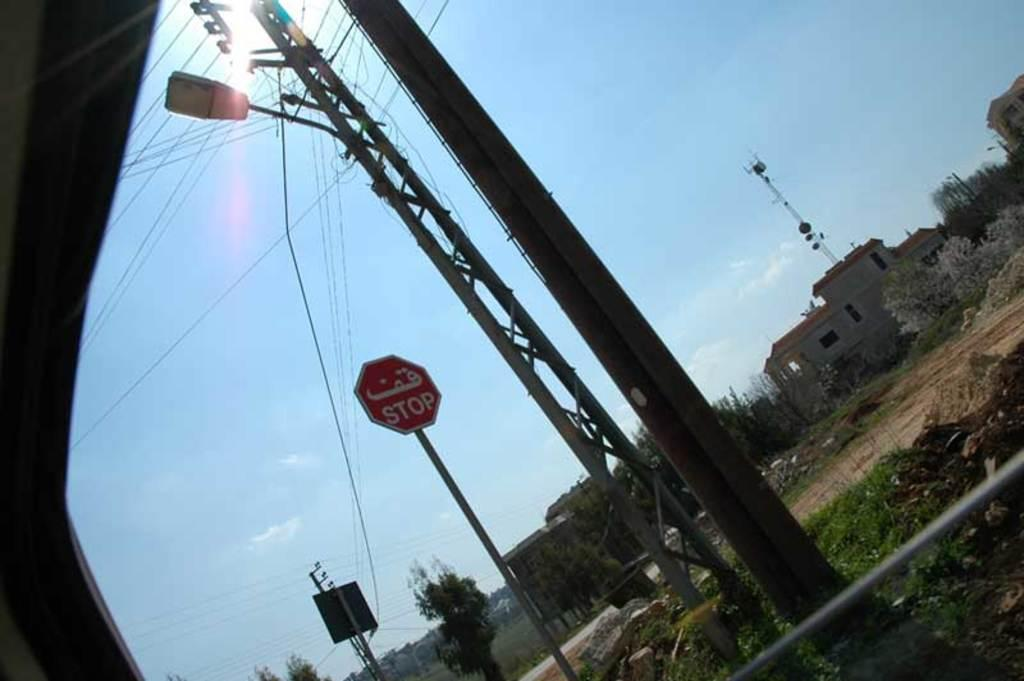What type of structures are present in the image? There are sign boards, poles, power line cables, trees, buildings, and stones visible in the image. What type of surface can be seen in the image? A road is visible in the image. What is visible at the top of the image? There is a sunset at the top of the image. What is the background of the image? The sky is visible in the image. How many sisters are playing basketball in the image? There are no sisters or basketball present in the image. What type of metal is used to make the lead in the image? There is no lead present in the image, and therefore no metal can be identified. 